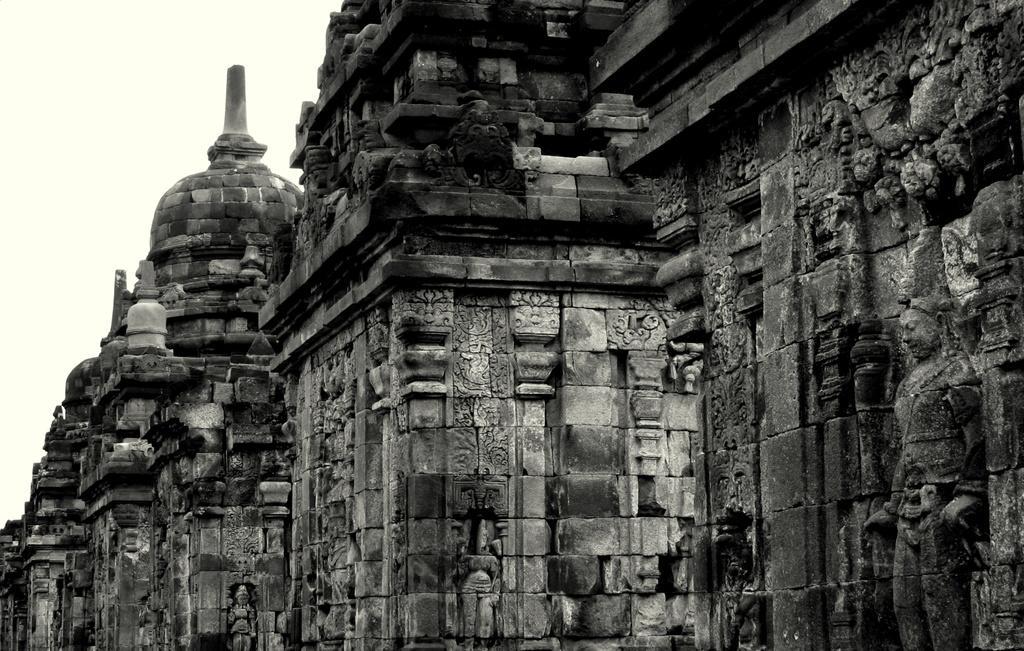Describe this image in one or two sentences. In this image we can see a historical building. In the background there is sky. 